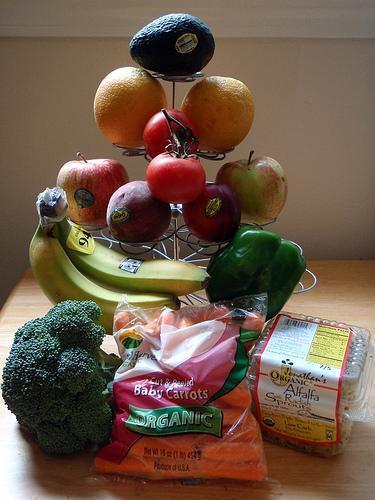How many carrots are there?
Give a very brief answer. 1. How many apples are there?
Give a very brief answer. 4. How many people (in front and focus of the photo) have no birds on their shoulders?
Give a very brief answer. 0. 